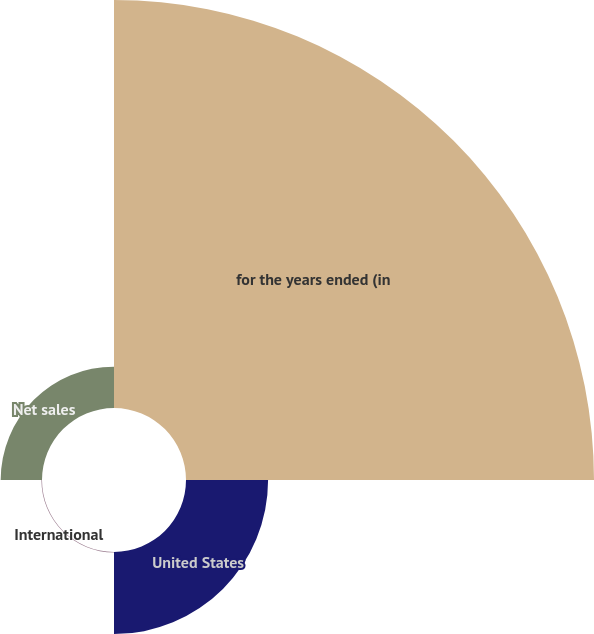Convert chart. <chart><loc_0><loc_0><loc_500><loc_500><pie_chart><fcel>for the years ended (in<fcel>United States<fcel>International<fcel>Net sales<nl><fcel>76.69%<fcel>15.43%<fcel>0.11%<fcel>7.77%<nl></chart> 